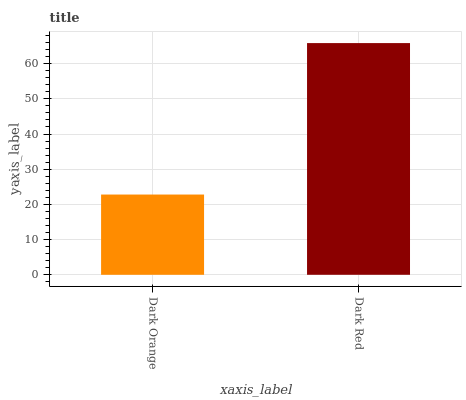Is Dark Red the minimum?
Answer yes or no. No. Is Dark Red greater than Dark Orange?
Answer yes or no. Yes. Is Dark Orange less than Dark Red?
Answer yes or no. Yes. Is Dark Orange greater than Dark Red?
Answer yes or no. No. Is Dark Red less than Dark Orange?
Answer yes or no. No. Is Dark Red the high median?
Answer yes or no. Yes. Is Dark Orange the low median?
Answer yes or no. Yes. Is Dark Orange the high median?
Answer yes or no. No. Is Dark Red the low median?
Answer yes or no. No. 